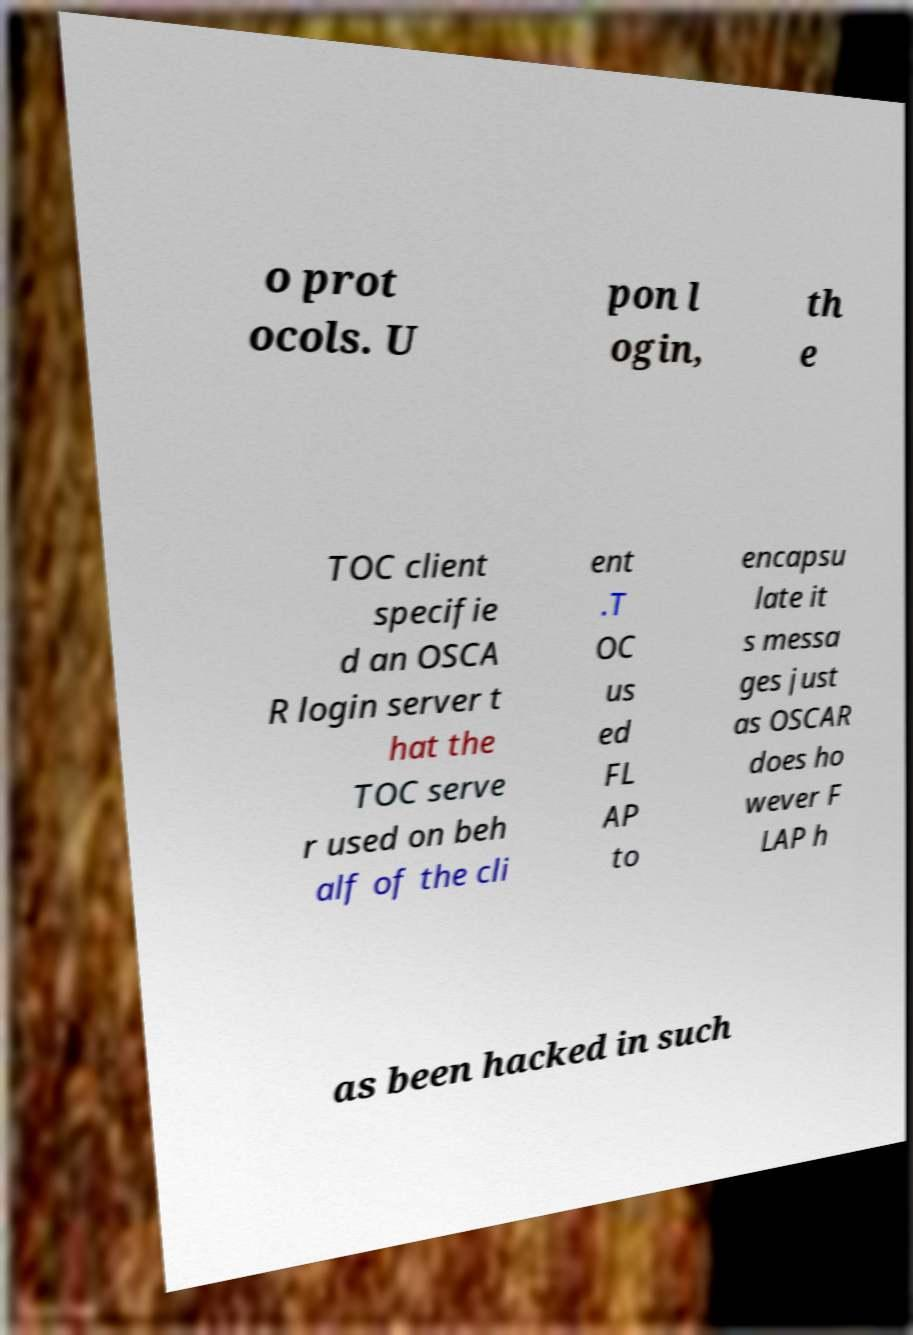Please read and relay the text visible in this image. What does it say? o prot ocols. U pon l ogin, th e TOC client specifie d an OSCA R login server t hat the TOC serve r used on beh alf of the cli ent .T OC us ed FL AP to encapsu late it s messa ges just as OSCAR does ho wever F LAP h as been hacked in such 